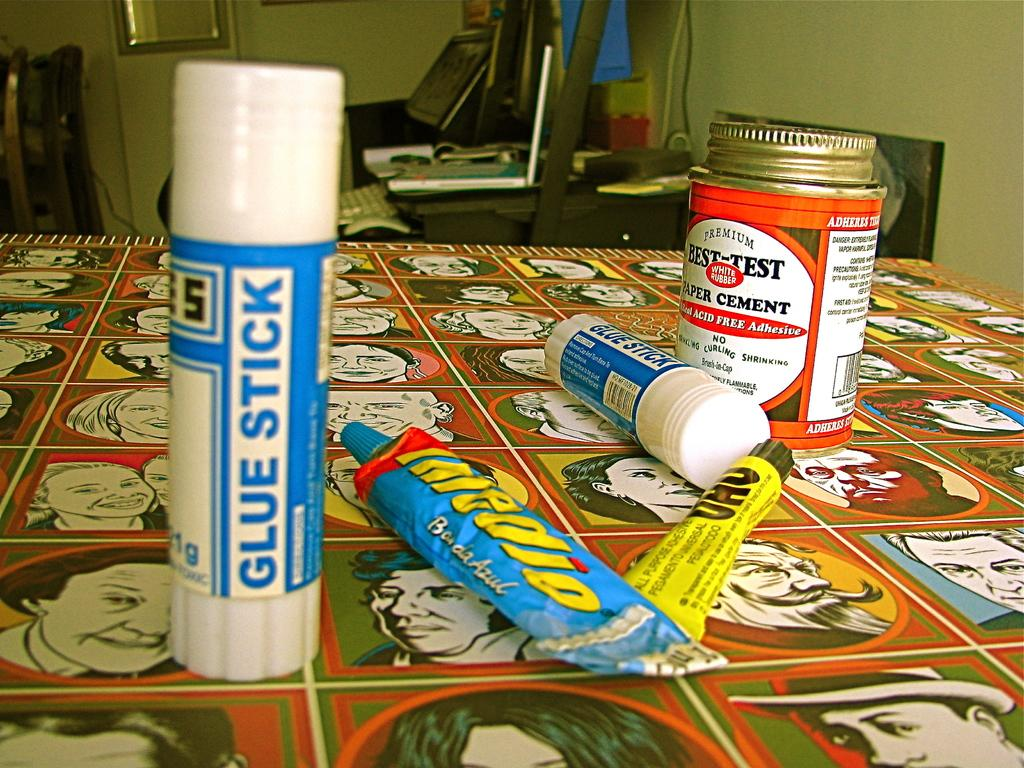<image>
Present a compact description of the photo's key features. The blue and white glue stick reads glue stick 